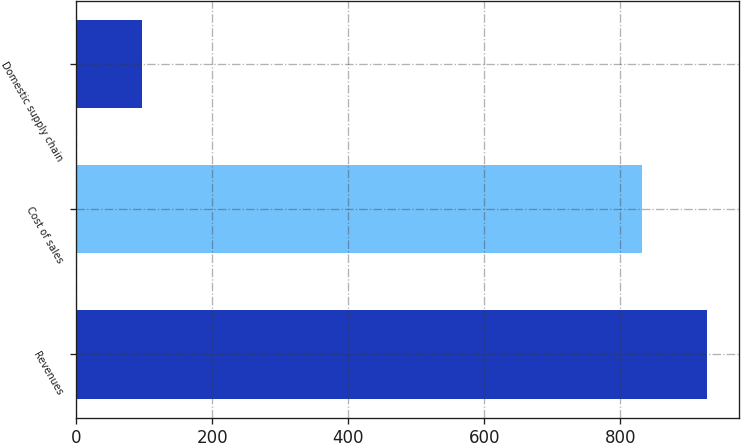Convert chart to OTSL. <chart><loc_0><loc_0><loc_500><loc_500><bar_chart><fcel>Revenues<fcel>Cost of sales<fcel>Domestic supply chain<nl><fcel>927.9<fcel>831.7<fcel>96.2<nl></chart> 